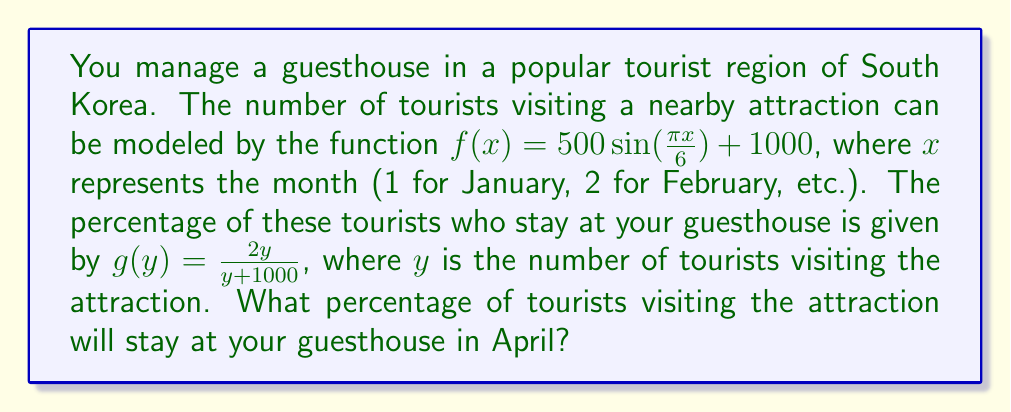Solve this math problem. To solve this problem, we need to use composite functions. We'll follow these steps:

1) First, we need to find the number of tourists visiting the attraction in April (month 4):
   $$f(4) = 500 \sin(\frac{\pi \cdot 4}{6}) + 1000$$
   $$= 500 \sin(\frac{2\pi}{3}) + 1000$$
   $$= 500 \cdot \frac{\sqrt{3}}{2} + 1000$$
   $$= 250\sqrt{3} + 1000 \approx 1433$$

2) Now that we know the number of tourists visiting the attraction, we can use this as input for the function $g$:
   $$g(f(4)) = g(1433) = \frac{2 \cdot 1433}{1433 + 1000}$$

3) Let's simplify this fraction:
   $$\frac{2866}{2433} \approx 1.178$$

4) To convert to a percentage, we multiply by 100:
   $$1.178 \cdot 100 \approx 117.8\%$$

Therefore, approximately 117.8% of the tourists visiting the attraction will stay at your guesthouse in April.
Answer: $117.8\%$ 